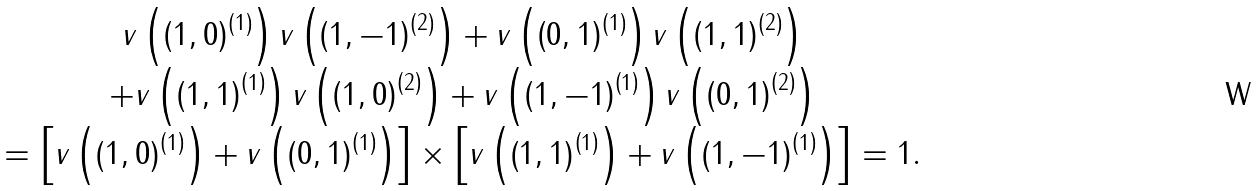Convert formula to latex. <formula><loc_0><loc_0><loc_500><loc_500>\begin{array} { c } v \left ( \left ( 1 , 0 \right ) ^ { \left ( 1 \right ) } \right ) v \left ( \left ( 1 , - 1 \right ) ^ { \left ( 2 \right ) } \right ) + v \left ( \left ( 0 , 1 \right ) ^ { \left ( 1 \right ) } \right ) v \left ( \left ( 1 , 1 \right ) ^ { \left ( 2 \right ) } \right ) \\ + v \left ( \left ( 1 , 1 \right ) ^ { \left ( 1 \right ) } \right ) v \left ( \left ( 1 , 0 \right ) ^ { \left ( 2 \right ) } \right ) + v \left ( \left ( 1 , - 1 \right ) ^ { \left ( 1 \right ) } \right ) v \left ( \left ( 0 , 1 \right ) ^ { \left ( 2 \right ) } \right ) \\ = \left [ v \left ( \left ( 1 , 0 \right ) ^ { \left ( 1 \right ) } \right ) + v \left ( \left ( 0 , 1 \right ) ^ { \left ( 1 \right ) } \right ) \right ] \times \left [ v \left ( \left ( 1 , 1 \right ) ^ { \left ( 1 \right ) } \right ) + v \left ( \left ( 1 , - 1 \right ) ^ { \left ( 1 \right ) } \right ) \right ] = 1 . \end{array}</formula> 